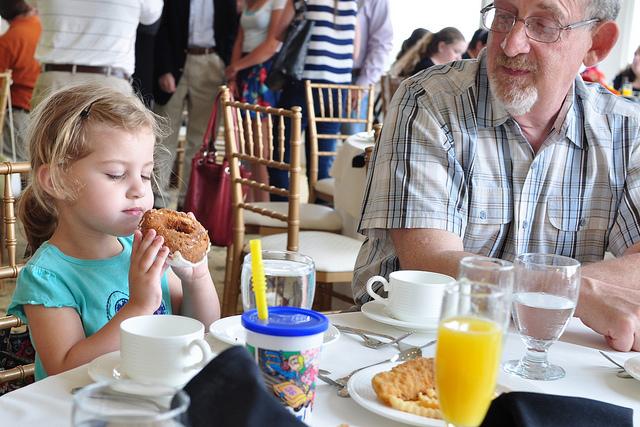What is the girl eating?
Be succinct. Donut. What color is the girl's shirt?
Write a very short answer. Blue. Are they at home?
Be succinct. No. 